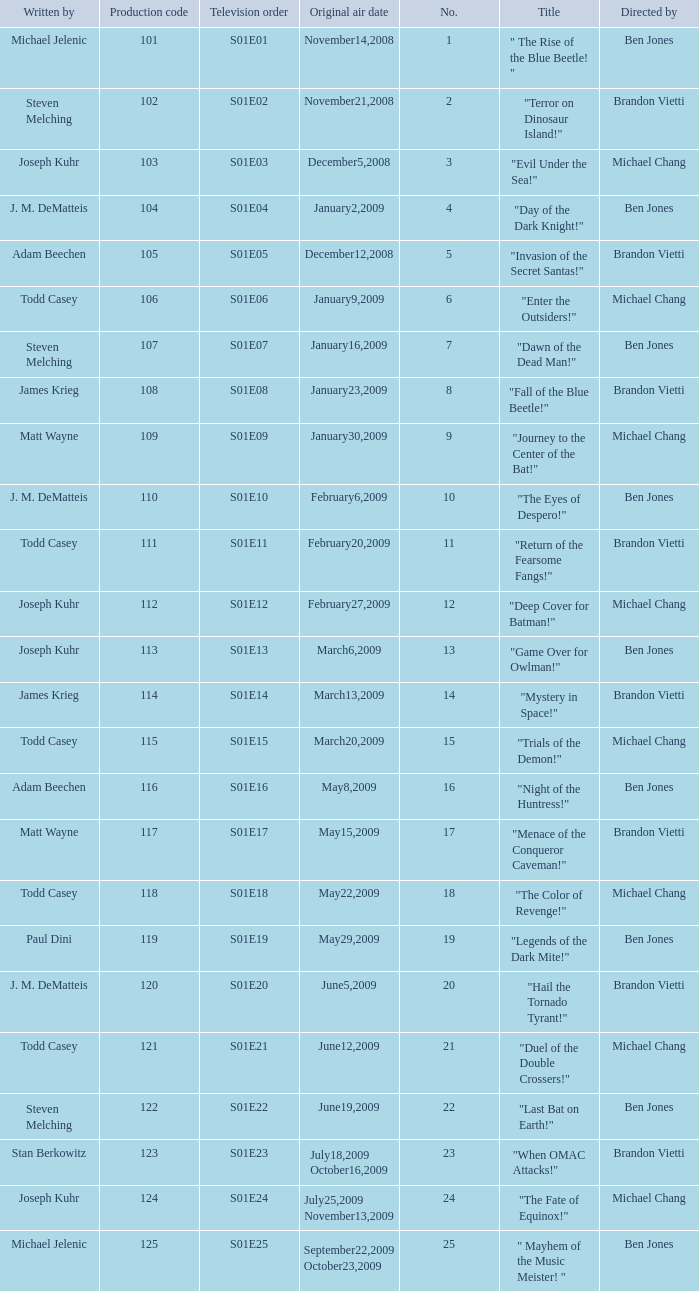What is the television order of the episode directed by ben jones, written by j. m. dematteis and originally aired on february6,2009 S01E10. 